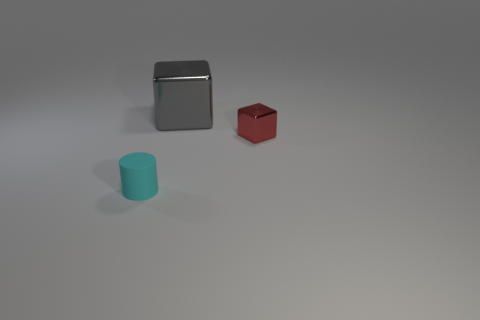Does the tiny thing that is behind the cyan rubber cylinder have the same color as the thing behind the red cube?
Your response must be concise. No. What number of other objects are there of the same shape as the large object?
Make the answer very short. 1. Is there a red thing?
Give a very brief answer. Yes. What number of objects are either small metallic cubes or small objects that are right of the cyan matte cylinder?
Make the answer very short. 1. There is a metal block that is behind the red block; is its size the same as the tiny rubber thing?
Your answer should be compact. No. How many other things are the same size as the red thing?
Your answer should be compact. 1. What is the color of the big thing?
Provide a succinct answer. Gray. There is a small thing on the right side of the cyan matte cylinder; what material is it?
Keep it short and to the point. Metal. Are there an equal number of tiny cyan cylinders that are behind the cyan object and large objects?
Your response must be concise. No. Does the tiny red object have the same shape as the tiny cyan matte object?
Your answer should be very brief. No. 